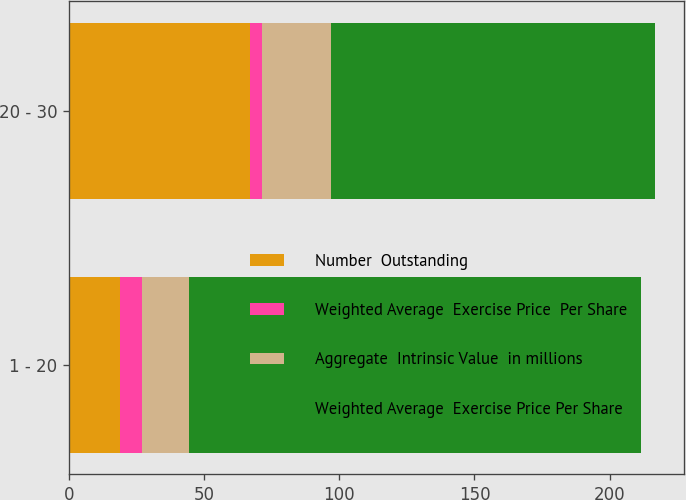<chart> <loc_0><loc_0><loc_500><loc_500><stacked_bar_chart><ecel><fcel>1 - 20<fcel>20 - 30<nl><fcel>Number  Outstanding<fcel>19<fcel>67<nl><fcel>Weighted Average  Exercise Price  Per Share<fcel>8.15<fcel>4.55<nl><fcel>Aggregate  Intrinsic Value  in millions<fcel>17.42<fcel>25.22<nl><fcel>Weighted Average  Exercise Price Per Share<fcel>167<fcel>120<nl></chart> 